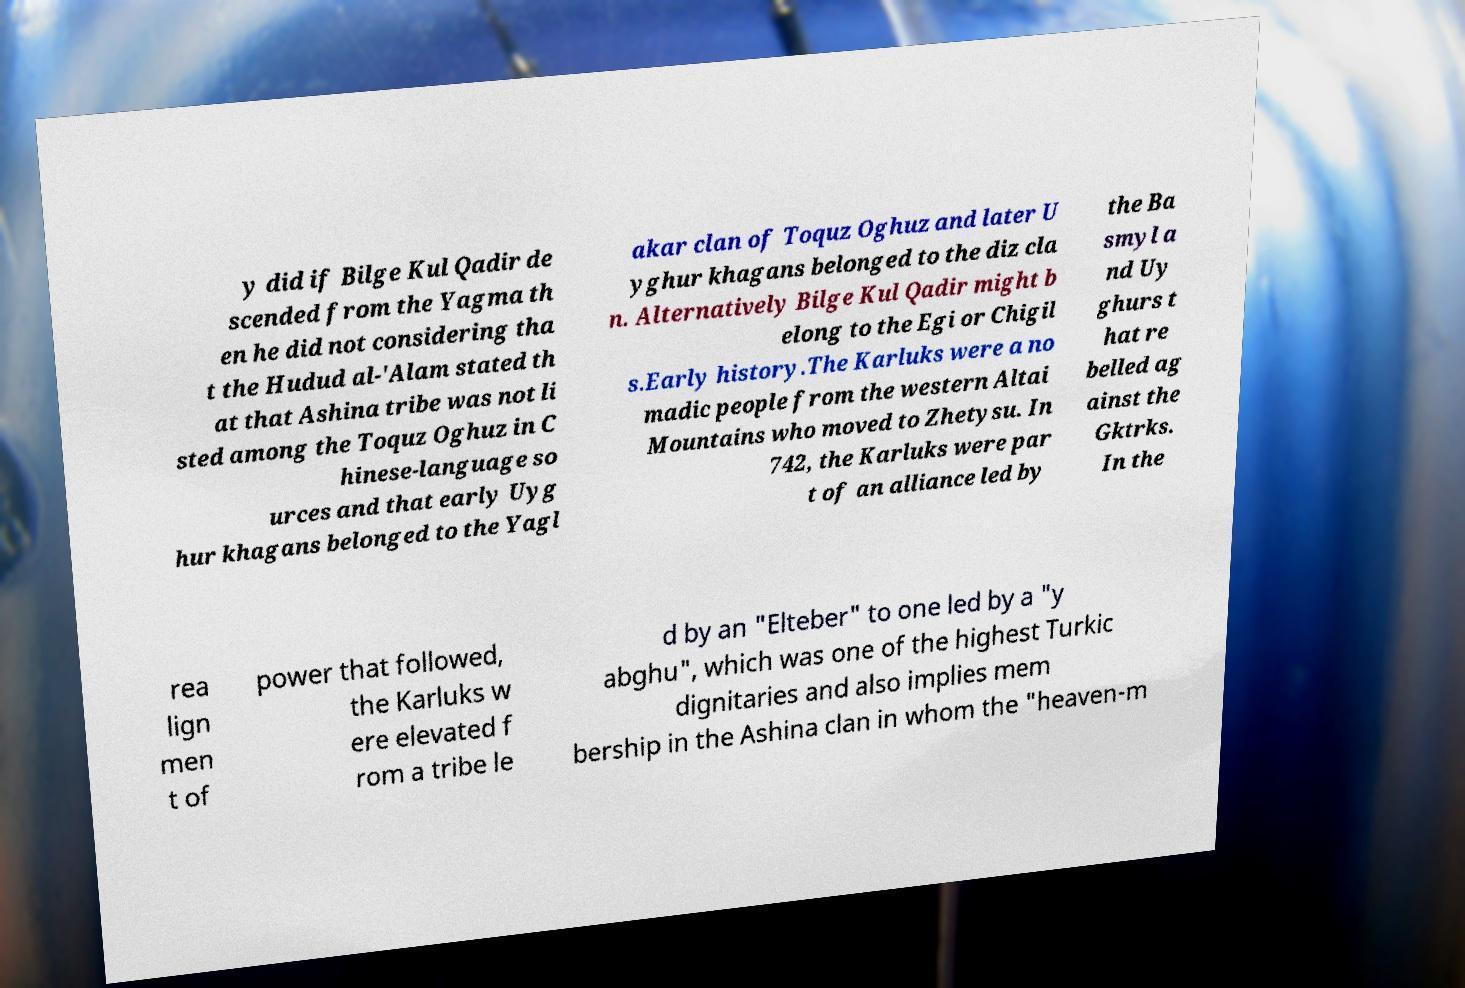There's text embedded in this image that I need extracted. Can you transcribe it verbatim? y did if Bilge Kul Qadir de scended from the Yagma th en he did not considering tha t the Hudud al-'Alam stated th at that Ashina tribe was not li sted among the Toquz Oghuz in C hinese-language so urces and that early Uyg hur khagans belonged to the Yagl akar clan of Toquz Oghuz and later U yghur khagans belonged to the diz cla n. Alternatively Bilge Kul Qadir might b elong to the Egi or Chigil s.Early history.The Karluks were a no madic people from the western Altai Mountains who moved to Zhetysu. In 742, the Karluks were par t of an alliance led by the Ba smyl a nd Uy ghurs t hat re belled ag ainst the Gktrks. In the rea lign men t of power that followed, the Karluks w ere elevated f rom a tribe le d by an "Elteber" to one led by a "y abghu", which was one of the highest Turkic dignitaries and also implies mem bership in the Ashina clan in whom the "heaven-m 